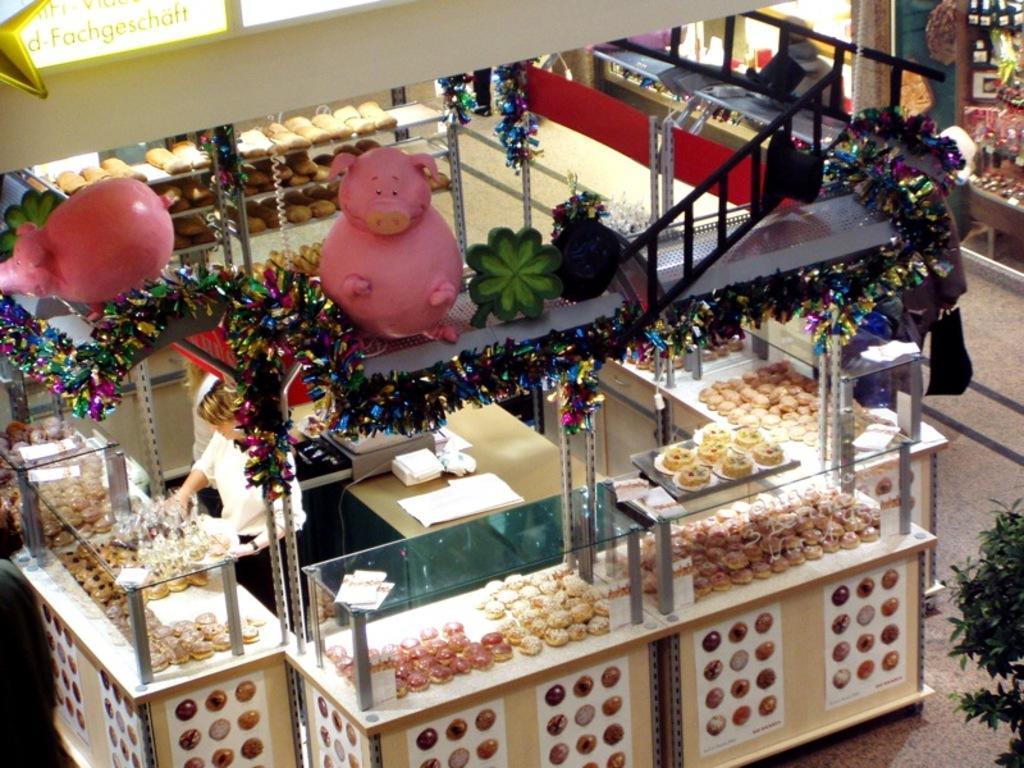Could you give a brief overview of what you see in this image? As we can see in the image there are boxes, decorative items, two persons wearing white color dresses, few dishes and on the right side there is plant. 